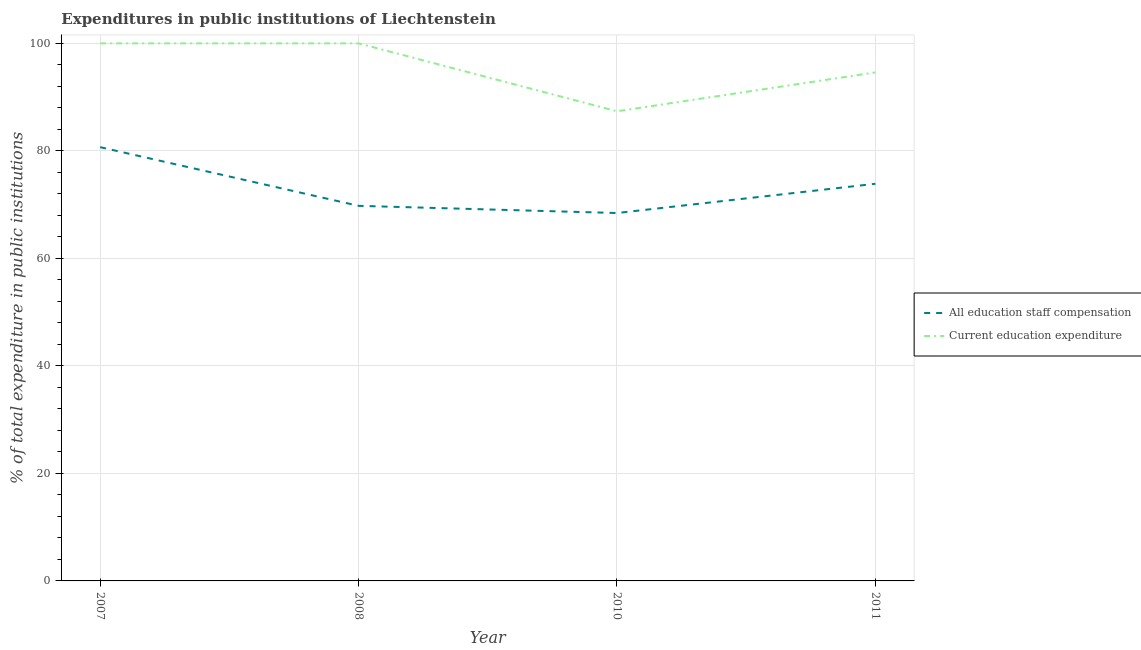How many different coloured lines are there?
Give a very brief answer. 2. Does the line corresponding to expenditure in staff compensation intersect with the line corresponding to expenditure in education?
Make the answer very short. No. Across all years, what is the maximum expenditure in education?
Your answer should be very brief. 100. Across all years, what is the minimum expenditure in education?
Your response must be concise. 87.37. In which year was the expenditure in staff compensation minimum?
Your answer should be very brief. 2010. What is the total expenditure in staff compensation in the graph?
Ensure brevity in your answer.  292.78. What is the difference between the expenditure in staff compensation in 2008 and that in 2011?
Keep it short and to the point. -4.1. What is the difference between the expenditure in staff compensation in 2011 and the expenditure in education in 2008?
Keep it short and to the point. -26.12. What is the average expenditure in staff compensation per year?
Provide a short and direct response. 73.2. In the year 2008, what is the difference between the expenditure in education and expenditure in staff compensation?
Provide a succinct answer. 30.23. In how many years, is the expenditure in education greater than 68 %?
Give a very brief answer. 4. What is the ratio of the expenditure in staff compensation in 2007 to that in 2010?
Your answer should be compact. 1.18. What is the difference between the highest and the second highest expenditure in staff compensation?
Offer a terse response. 6.81. What is the difference between the highest and the lowest expenditure in education?
Your answer should be compact. 12.63. How many lines are there?
Offer a very short reply. 2. Does the graph contain any zero values?
Keep it short and to the point. No. Where does the legend appear in the graph?
Your response must be concise. Center right. How many legend labels are there?
Ensure brevity in your answer.  2. What is the title of the graph?
Your answer should be very brief. Expenditures in public institutions of Liechtenstein. Does "Imports" appear as one of the legend labels in the graph?
Give a very brief answer. No. What is the label or title of the Y-axis?
Make the answer very short. % of total expenditure in public institutions. What is the % of total expenditure in public institutions in All education staff compensation in 2007?
Your response must be concise. 80.69. What is the % of total expenditure in public institutions of All education staff compensation in 2008?
Provide a succinct answer. 69.77. What is the % of total expenditure in public institutions of Current education expenditure in 2008?
Make the answer very short. 100. What is the % of total expenditure in public institutions of All education staff compensation in 2010?
Your answer should be compact. 68.44. What is the % of total expenditure in public institutions in Current education expenditure in 2010?
Provide a short and direct response. 87.37. What is the % of total expenditure in public institutions of All education staff compensation in 2011?
Your answer should be very brief. 73.88. What is the % of total expenditure in public institutions in Current education expenditure in 2011?
Offer a terse response. 94.6. Across all years, what is the maximum % of total expenditure in public institutions in All education staff compensation?
Your answer should be compact. 80.69. Across all years, what is the maximum % of total expenditure in public institutions in Current education expenditure?
Ensure brevity in your answer.  100. Across all years, what is the minimum % of total expenditure in public institutions in All education staff compensation?
Make the answer very short. 68.44. Across all years, what is the minimum % of total expenditure in public institutions in Current education expenditure?
Give a very brief answer. 87.37. What is the total % of total expenditure in public institutions of All education staff compensation in the graph?
Offer a very short reply. 292.78. What is the total % of total expenditure in public institutions of Current education expenditure in the graph?
Ensure brevity in your answer.  381.97. What is the difference between the % of total expenditure in public institutions in All education staff compensation in 2007 and that in 2008?
Ensure brevity in your answer.  10.92. What is the difference between the % of total expenditure in public institutions in Current education expenditure in 2007 and that in 2008?
Keep it short and to the point. 0. What is the difference between the % of total expenditure in public institutions of All education staff compensation in 2007 and that in 2010?
Give a very brief answer. 12.25. What is the difference between the % of total expenditure in public institutions in Current education expenditure in 2007 and that in 2010?
Make the answer very short. 12.63. What is the difference between the % of total expenditure in public institutions in All education staff compensation in 2007 and that in 2011?
Your answer should be compact. 6.81. What is the difference between the % of total expenditure in public institutions of Current education expenditure in 2007 and that in 2011?
Your answer should be very brief. 5.4. What is the difference between the % of total expenditure in public institutions in All education staff compensation in 2008 and that in 2010?
Offer a very short reply. 1.34. What is the difference between the % of total expenditure in public institutions in Current education expenditure in 2008 and that in 2010?
Make the answer very short. 12.63. What is the difference between the % of total expenditure in public institutions in All education staff compensation in 2008 and that in 2011?
Keep it short and to the point. -4.1. What is the difference between the % of total expenditure in public institutions in Current education expenditure in 2008 and that in 2011?
Offer a very short reply. 5.4. What is the difference between the % of total expenditure in public institutions of All education staff compensation in 2010 and that in 2011?
Your answer should be very brief. -5.44. What is the difference between the % of total expenditure in public institutions in Current education expenditure in 2010 and that in 2011?
Ensure brevity in your answer.  -7.23. What is the difference between the % of total expenditure in public institutions in All education staff compensation in 2007 and the % of total expenditure in public institutions in Current education expenditure in 2008?
Make the answer very short. -19.31. What is the difference between the % of total expenditure in public institutions of All education staff compensation in 2007 and the % of total expenditure in public institutions of Current education expenditure in 2010?
Keep it short and to the point. -6.68. What is the difference between the % of total expenditure in public institutions in All education staff compensation in 2007 and the % of total expenditure in public institutions in Current education expenditure in 2011?
Keep it short and to the point. -13.91. What is the difference between the % of total expenditure in public institutions in All education staff compensation in 2008 and the % of total expenditure in public institutions in Current education expenditure in 2010?
Make the answer very short. -17.59. What is the difference between the % of total expenditure in public institutions in All education staff compensation in 2008 and the % of total expenditure in public institutions in Current education expenditure in 2011?
Provide a succinct answer. -24.82. What is the difference between the % of total expenditure in public institutions in All education staff compensation in 2010 and the % of total expenditure in public institutions in Current education expenditure in 2011?
Offer a terse response. -26.16. What is the average % of total expenditure in public institutions of All education staff compensation per year?
Your response must be concise. 73.2. What is the average % of total expenditure in public institutions in Current education expenditure per year?
Keep it short and to the point. 95.49. In the year 2007, what is the difference between the % of total expenditure in public institutions in All education staff compensation and % of total expenditure in public institutions in Current education expenditure?
Make the answer very short. -19.31. In the year 2008, what is the difference between the % of total expenditure in public institutions of All education staff compensation and % of total expenditure in public institutions of Current education expenditure?
Ensure brevity in your answer.  -30.23. In the year 2010, what is the difference between the % of total expenditure in public institutions in All education staff compensation and % of total expenditure in public institutions in Current education expenditure?
Provide a succinct answer. -18.93. In the year 2011, what is the difference between the % of total expenditure in public institutions in All education staff compensation and % of total expenditure in public institutions in Current education expenditure?
Your answer should be very brief. -20.72. What is the ratio of the % of total expenditure in public institutions of All education staff compensation in 2007 to that in 2008?
Keep it short and to the point. 1.16. What is the ratio of the % of total expenditure in public institutions in All education staff compensation in 2007 to that in 2010?
Provide a succinct answer. 1.18. What is the ratio of the % of total expenditure in public institutions in Current education expenditure in 2007 to that in 2010?
Give a very brief answer. 1.14. What is the ratio of the % of total expenditure in public institutions of All education staff compensation in 2007 to that in 2011?
Provide a succinct answer. 1.09. What is the ratio of the % of total expenditure in public institutions of Current education expenditure in 2007 to that in 2011?
Ensure brevity in your answer.  1.06. What is the ratio of the % of total expenditure in public institutions of All education staff compensation in 2008 to that in 2010?
Your answer should be compact. 1.02. What is the ratio of the % of total expenditure in public institutions of Current education expenditure in 2008 to that in 2010?
Your answer should be very brief. 1.14. What is the ratio of the % of total expenditure in public institutions in All education staff compensation in 2008 to that in 2011?
Ensure brevity in your answer.  0.94. What is the ratio of the % of total expenditure in public institutions of Current education expenditure in 2008 to that in 2011?
Your answer should be compact. 1.06. What is the ratio of the % of total expenditure in public institutions in All education staff compensation in 2010 to that in 2011?
Keep it short and to the point. 0.93. What is the ratio of the % of total expenditure in public institutions in Current education expenditure in 2010 to that in 2011?
Offer a very short reply. 0.92. What is the difference between the highest and the second highest % of total expenditure in public institutions in All education staff compensation?
Keep it short and to the point. 6.81. What is the difference between the highest and the second highest % of total expenditure in public institutions in Current education expenditure?
Offer a terse response. 0. What is the difference between the highest and the lowest % of total expenditure in public institutions of All education staff compensation?
Your response must be concise. 12.25. What is the difference between the highest and the lowest % of total expenditure in public institutions in Current education expenditure?
Provide a short and direct response. 12.63. 